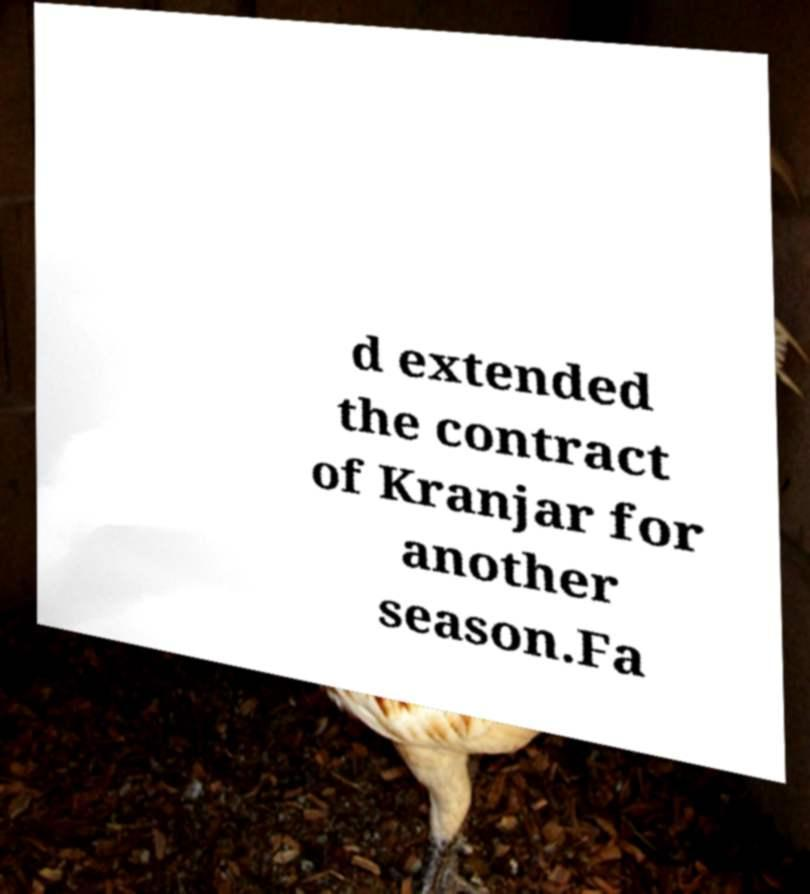Please read and relay the text visible in this image. What does it say? d extended the contract of Kranjar for another season.Fa 